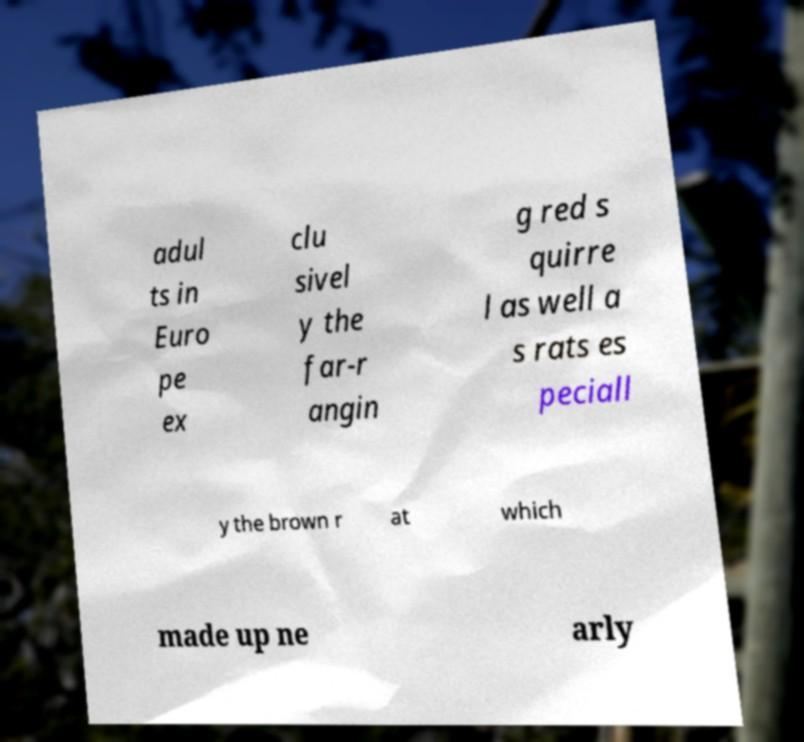Can you read and provide the text displayed in the image?This photo seems to have some interesting text. Can you extract and type it out for me? adul ts in Euro pe ex clu sivel y the far-r angin g red s quirre l as well a s rats es peciall y the brown r at which made up ne arly 